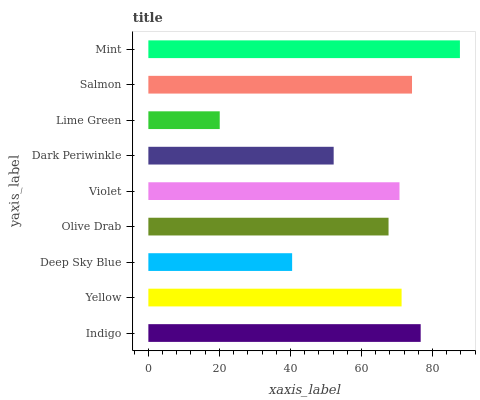Is Lime Green the minimum?
Answer yes or no. Yes. Is Mint the maximum?
Answer yes or no. Yes. Is Yellow the minimum?
Answer yes or no. No. Is Yellow the maximum?
Answer yes or no. No. Is Indigo greater than Yellow?
Answer yes or no. Yes. Is Yellow less than Indigo?
Answer yes or no. Yes. Is Yellow greater than Indigo?
Answer yes or no. No. Is Indigo less than Yellow?
Answer yes or no. No. Is Violet the high median?
Answer yes or no. Yes. Is Violet the low median?
Answer yes or no. Yes. Is Salmon the high median?
Answer yes or no. No. Is Deep Sky Blue the low median?
Answer yes or no. No. 